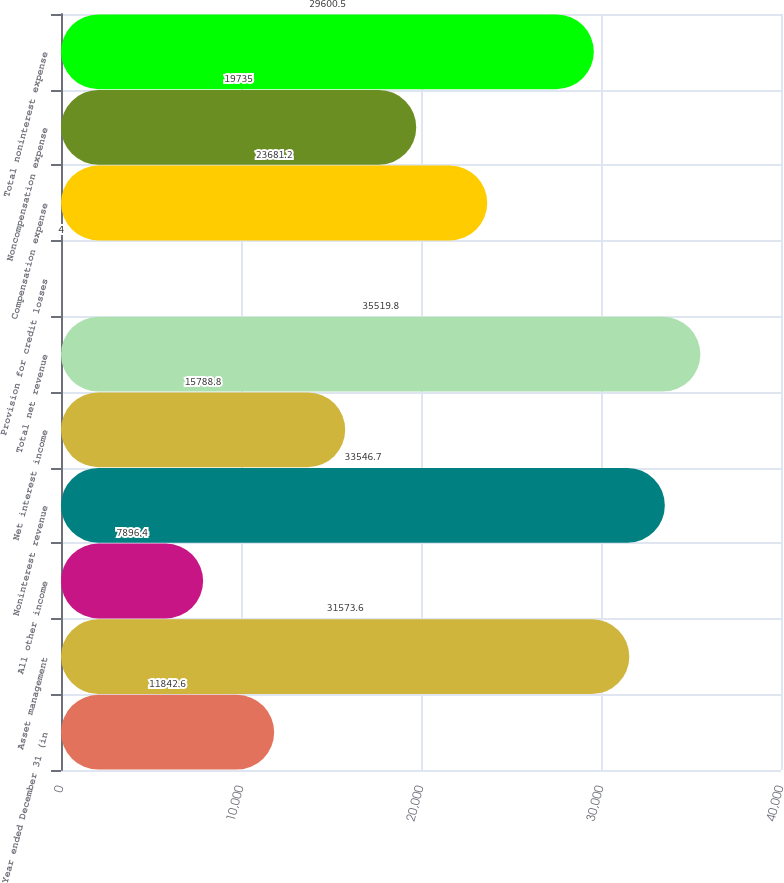Convert chart to OTSL. <chart><loc_0><loc_0><loc_500><loc_500><bar_chart><fcel>Year ended December 31 (in<fcel>Asset management<fcel>All other income<fcel>Noninterest revenue<fcel>Net interest income<fcel>Total net revenue<fcel>Provision for credit losses<fcel>Compensation expense<fcel>Noncompensation expense<fcel>Total noninterest expense<nl><fcel>11842.6<fcel>31573.6<fcel>7896.4<fcel>33546.7<fcel>15788.8<fcel>35519.8<fcel>4<fcel>23681.2<fcel>19735<fcel>29600.5<nl></chart> 